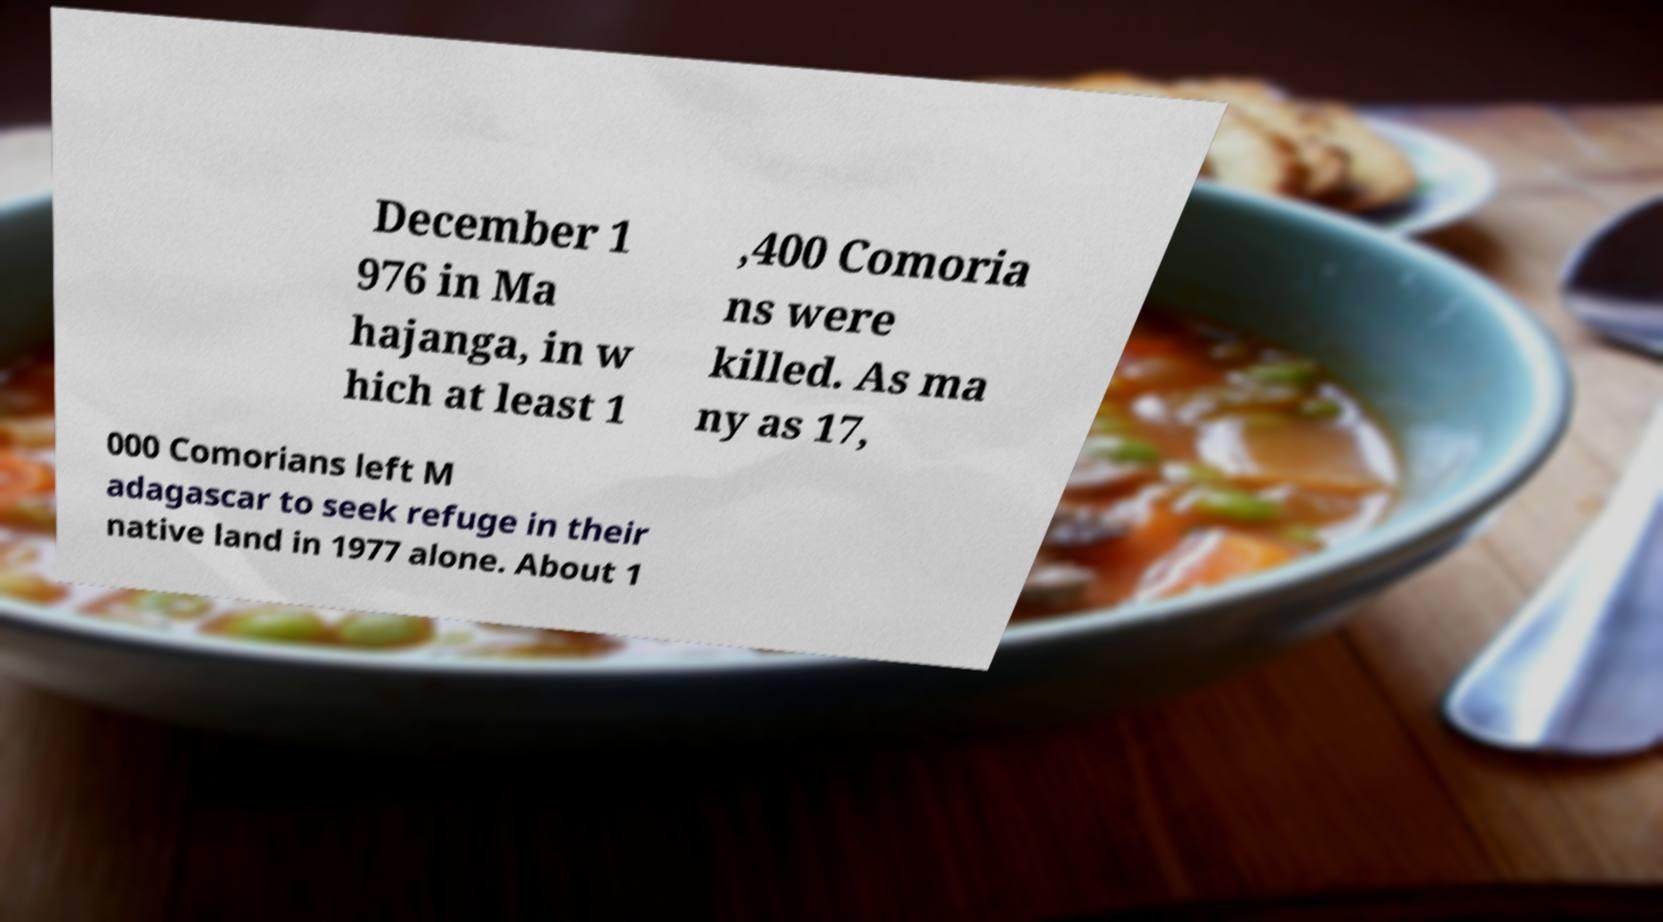I need the written content from this picture converted into text. Can you do that? December 1 976 in Ma hajanga, in w hich at least 1 ,400 Comoria ns were killed. As ma ny as 17, 000 Comorians left M adagascar to seek refuge in their native land in 1977 alone. About 1 